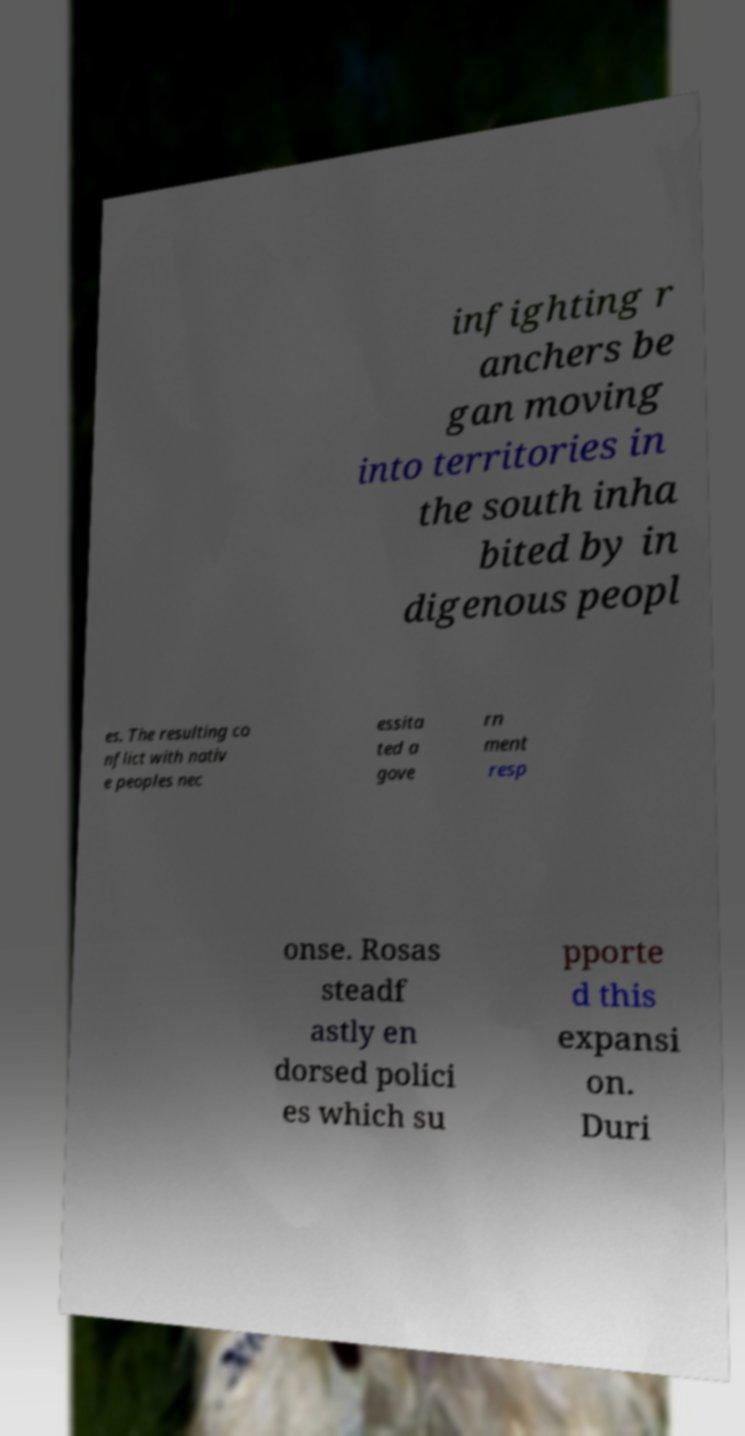There's text embedded in this image that I need extracted. Can you transcribe it verbatim? infighting r anchers be gan moving into territories in the south inha bited by in digenous peopl es. The resulting co nflict with nativ e peoples nec essita ted a gove rn ment resp onse. Rosas steadf astly en dorsed polici es which su pporte d this expansi on. Duri 